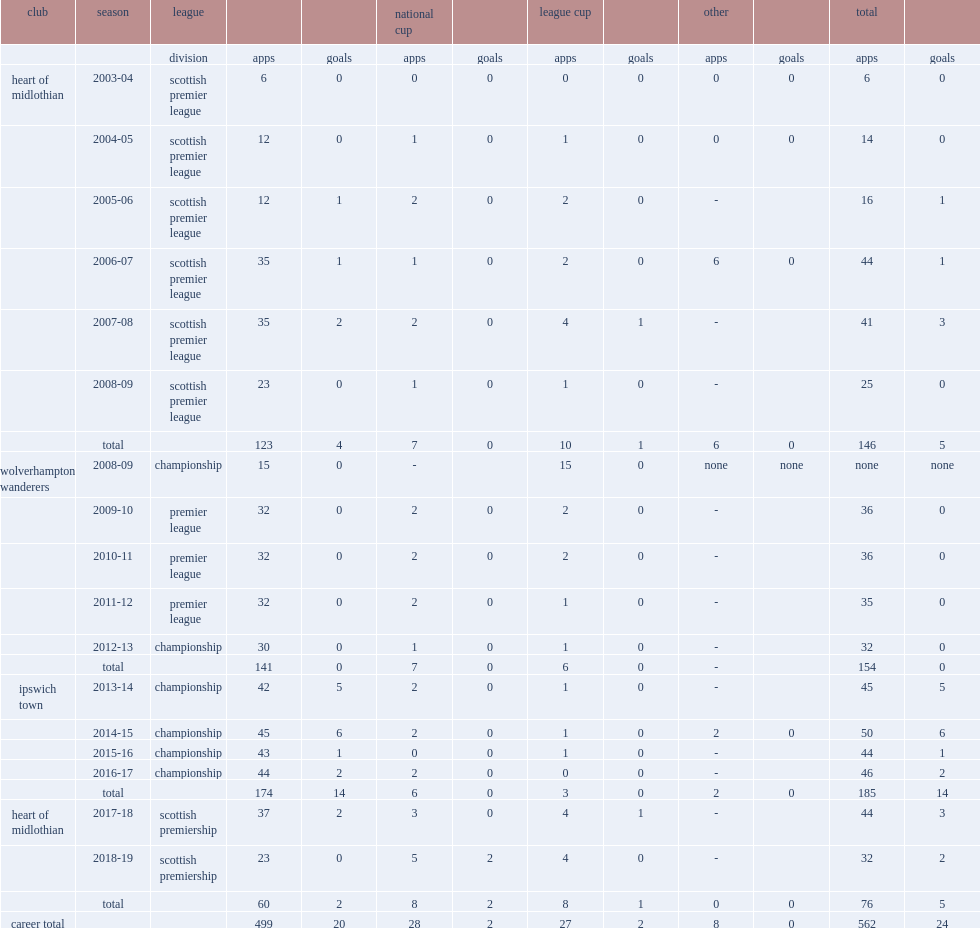Parse the full table. {'header': ['club', 'season', 'league', '', '', 'national cup', '', 'league cup', '', 'other', '', 'total', ''], 'rows': [['', '', 'division', 'apps', 'goals', 'apps', 'goals', 'apps', 'goals', 'apps', 'goals', 'apps', 'goals'], ['heart of midlothian', '2003-04', 'scottish premier league', '6', '0', '0', '0', '0', '0', '0', '0', '6', '0'], ['', '2004-05', 'scottish premier league', '12', '0', '1', '0', '1', '0', '0', '0', '14', '0'], ['', '2005-06', 'scottish premier league', '12', '1', '2', '0', '2', '0', '-', '', '16', '1'], ['', '2006-07', 'scottish premier league', '35', '1', '1', '0', '2', '0', '6', '0', '44', '1'], ['', '2007-08', 'scottish premier league', '35', '2', '2', '0', '4', '1', '-', '', '41', '3'], ['', '2008-09', 'scottish premier league', '23', '0', '1', '0', '1', '0', '-', '', '25', '0'], ['', 'total', '', '123', '4', '7', '0', '10', '1', '6', '0', '146', '5'], ['wolverhampton wanderers', '2008-09', 'championship', '15', '0', '-', '', '15', '0', 'none', 'none', 'none', 'none'], ['', '2009-10', 'premier league', '32', '0', '2', '0', '2', '0', '-', '', '36', '0'], ['', '2010-11', 'premier league', '32', '0', '2', '0', '2', '0', '-', '', '36', '0'], ['', '2011-12', 'premier league', '32', '0', '2', '0', '1', '0', '-', '', '35', '0'], ['', '2012-13', 'championship', '30', '0', '1', '0', '1', '0', '-', '', '32', '0'], ['', 'total', '', '141', '0', '7', '0', '6', '0', '-', '', '154', '0'], ['ipswich town', '2013-14', 'championship', '42', '5', '2', '0', '1', '0', '-', '', '45', '5'], ['', '2014-15', 'championship', '45', '6', '2', '0', '1', '0', '2', '0', '50', '6'], ['', '2015-16', 'championship', '43', '1', '0', '0', '1', '0', '-', '', '44', '1'], ['', '2016-17', 'championship', '44', '2', '2', '0', '0', '0', '-', '', '46', '2'], ['', 'total', '', '174', '14', '6', '0', '3', '0', '2', '0', '185', '14'], ['heart of midlothian', '2017-18', 'scottish premiership', '37', '2', '3', '0', '4', '1', '-', '', '44', '3'], ['', '2018-19', 'scottish premiership', '23', '0', '5', '2', '4', '0', '-', '', '32', '2'], ['', 'total', '', '60', '2', '8', '2', '8', '1', '0', '0', '76', '5'], ['career total', '', '', '499', '20', '28', '2', '27', '2', '8', '0', '562', '24']]} In total, how many apperances did christophe berra make wolverhampton wanderers without scoring? 154.0. 